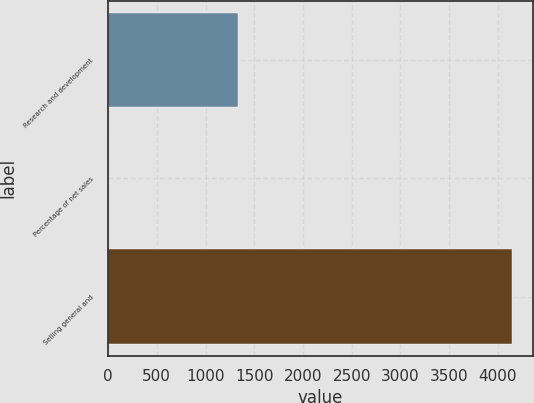<chart> <loc_0><loc_0><loc_500><loc_500><bar_chart><fcel>Research and development<fcel>Percentage of net sales<fcel>Selling general and<nl><fcel>1333<fcel>3.1<fcel>4149<nl></chart> 